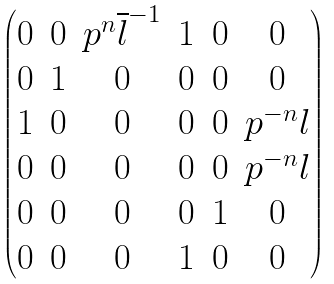Convert formula to latex. <formula><loc_0><loc_0><loc_500><loc_500>\begin{pmatrix} 0 & 0 & p ^ { n } \overline { l } ^ { - 1 } & 1 & 0 & 0 \\ 0 & 1 & 0 & 0 & 0 & 0 \\ 1 & 0 & 0 & 0 & 0 & p ^ { - n } l \\ 0 & 0 & 0 & 0 & 0 & p ^ { - n } l \\ 0 & 0 & 0 & 0 & 1 & 0 \\ 0 & 0 & 0 & 1 & 0 & 0 \end{pmatrix}</formula> 